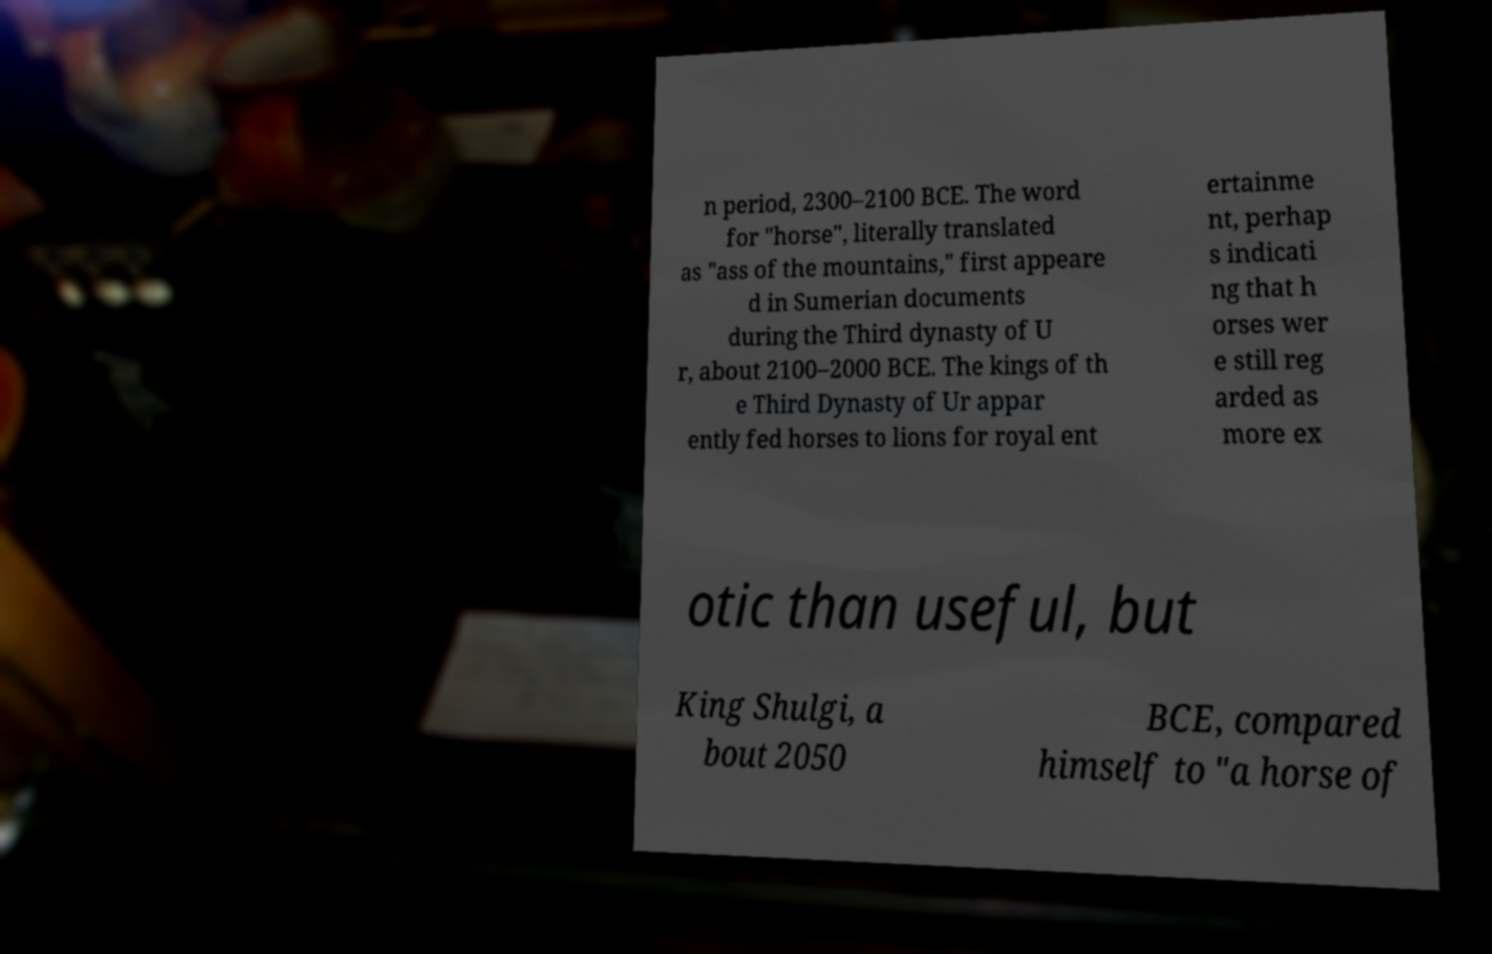Could you extract and type out the text from this image? n period, 2300–2100 BCE. The word for "horse", literally translated as "ass of the mountains," first appeare d in Sumerian documents during the Third dynasty of U r, about 2100–2000 BCE. The kings of th e Third Dynasty of Ur appar ently fed horses to lions for royal ent ertainme nt, perhap s indicati ng that h orses wer e still reg arded as more ex otic than useful, but King Shulgi, a bout 2050 BCE, compared himself to "a horse of 